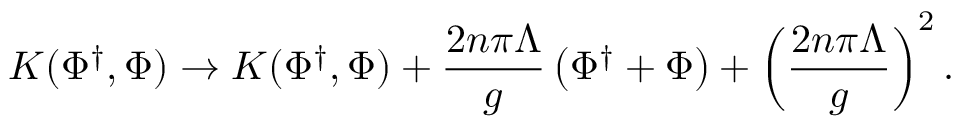<formula> <loc_0><loc_0><loc_500><loc_500>K ( \Phi ^ { \dagger } , \Phi ) \rightarrow K ( \Phi ^ { \dagger } , \Phi ) + { \frac { 2 n \pi \Lambda } { g } } \left ( \Phi ^ { \dagger } + \Phi \right ) + \left ( { \frac { 2 n \pi \Lambda } { g } } \right ) ^ { 2 } .</formula> 